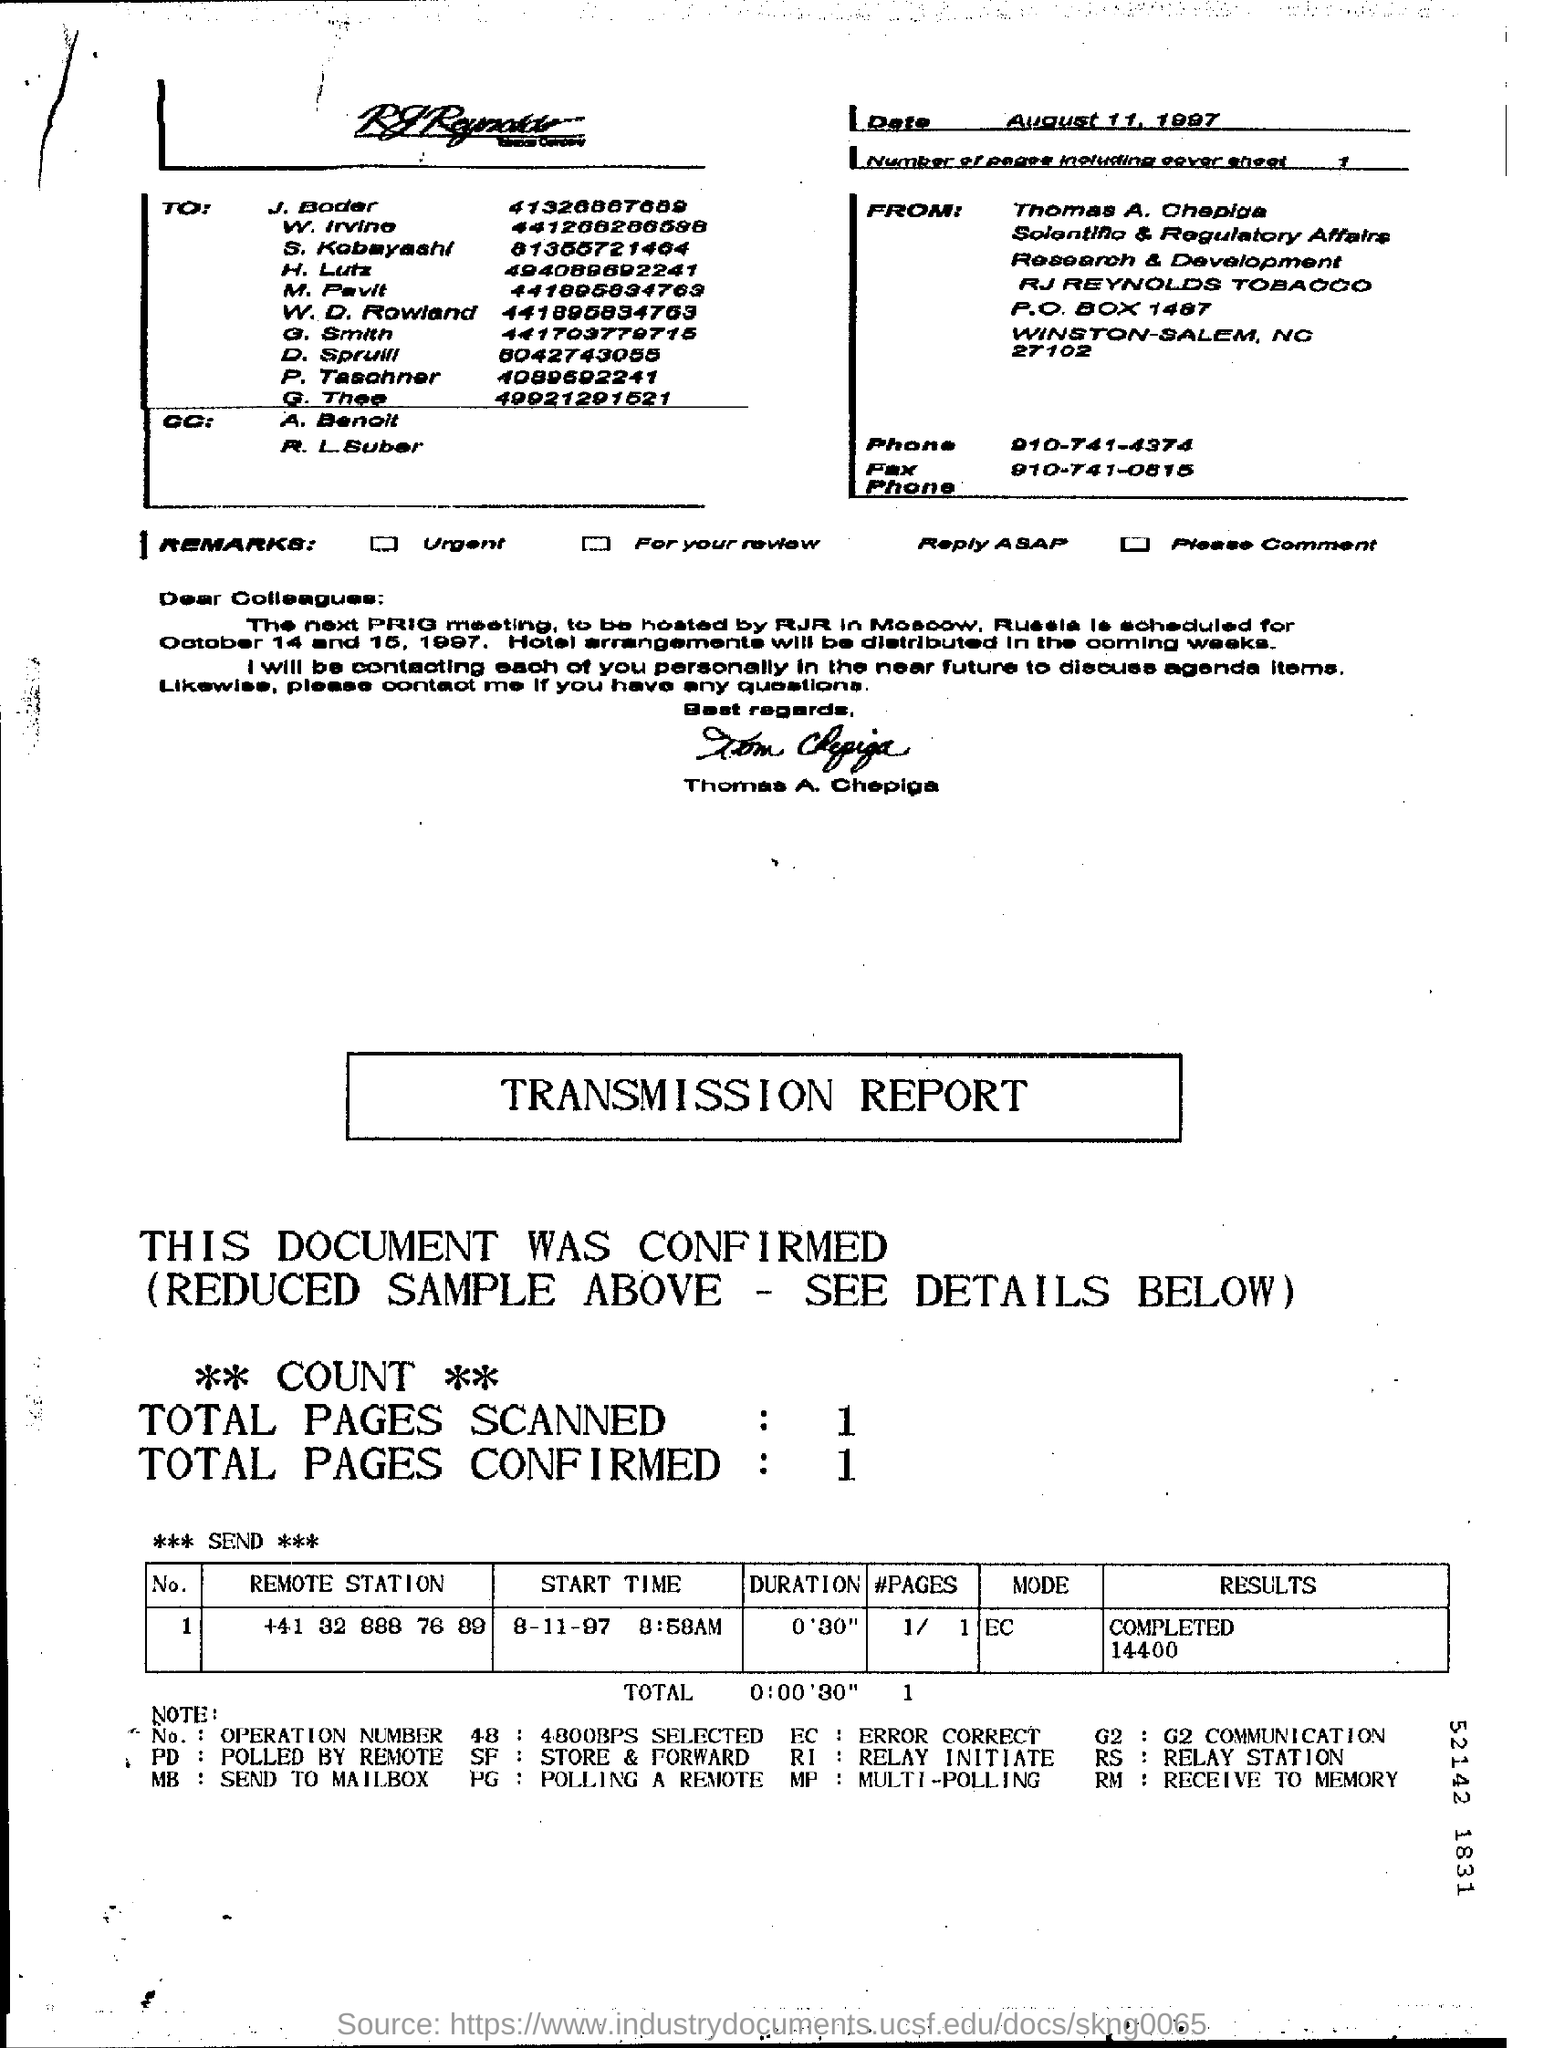When is the document dated?
Your answer should be compact. August 11, 1997. How many pages are there including cover sheet?
Your answer should be very brief. 1. Where is the next PRIG meeting to be hosted by RJR?
Keep it short and to the point. Moscow, Russia. What is the remote station number?
Keep it short and to the point. +41 32 888 76 89. 